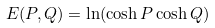Convert formula to latex. <formula><loc_0><loc_0><loc_500><loc_500>E ( P , Q ) = \ln ( \cosh P \cosh Q )</formula> 